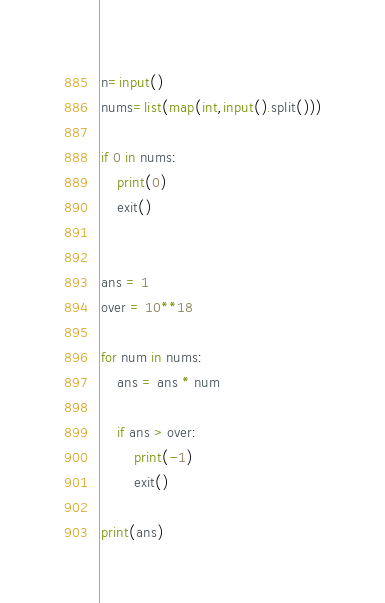Convert code to text. <code><loc_0><loc_0><loc_500><loc_500><_Python_>n=input()
nums=list(map(int,input().split()))

if 0 in nums:
    print(0)
    exit()


ans = 1
over = 10**18

for num in nums:
    ans = ans * num

    if ans > over:
        print(-1)
        exit()

print(ans)
</code> 